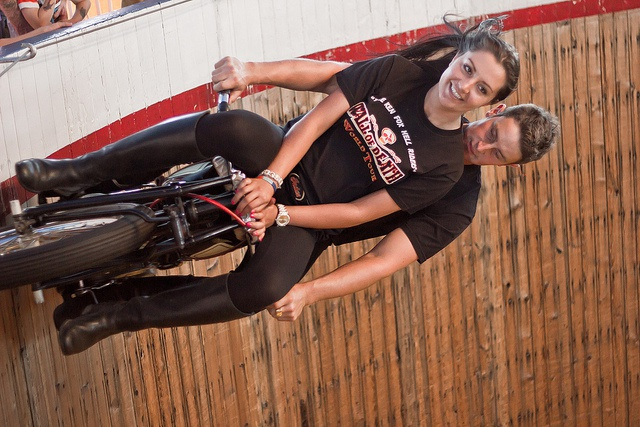Describe the objects in this image and their specific colors. I can see people in brown, black, maroon, and salmon tones, motorcycle in brown, black, maroon, and gray tones, people in brown, black, and salmon tones, people in brown, lightpink, and lightgray tones, and clock in brown, tan, and lightgray tones in this image. 